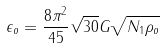Convert formula to latex. <formula><loc_0><loc_0><loc_500><loc_500>\epsilon _ { o } = \frac { 8 \pi ^ { 2 } } { 4 5 } \sqrt { 3 0 } G \sqrt { N _ { 1 } \rho _ { o } }</formula> 